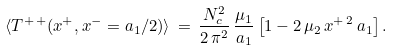Convert formula to latex. <formula><loc_0><loc_0><loc_500><loc_500>\langle T ^ { + \, + } ( x ^ { + } , x ^ { - } = a _ { 1 } / 2 ) \rangle \, = \, \frac { N _ { c } ^ { 2 } } { 2 \, \pi ^ { 2 } } \, \frac { \mu _ { 1 } } { a _ { 1 } } \left [ 1 - 2 \, \mu _ { 2 } \, x ^ { + \, 2 } \, a _ { 1 } \right ] .</formula> 